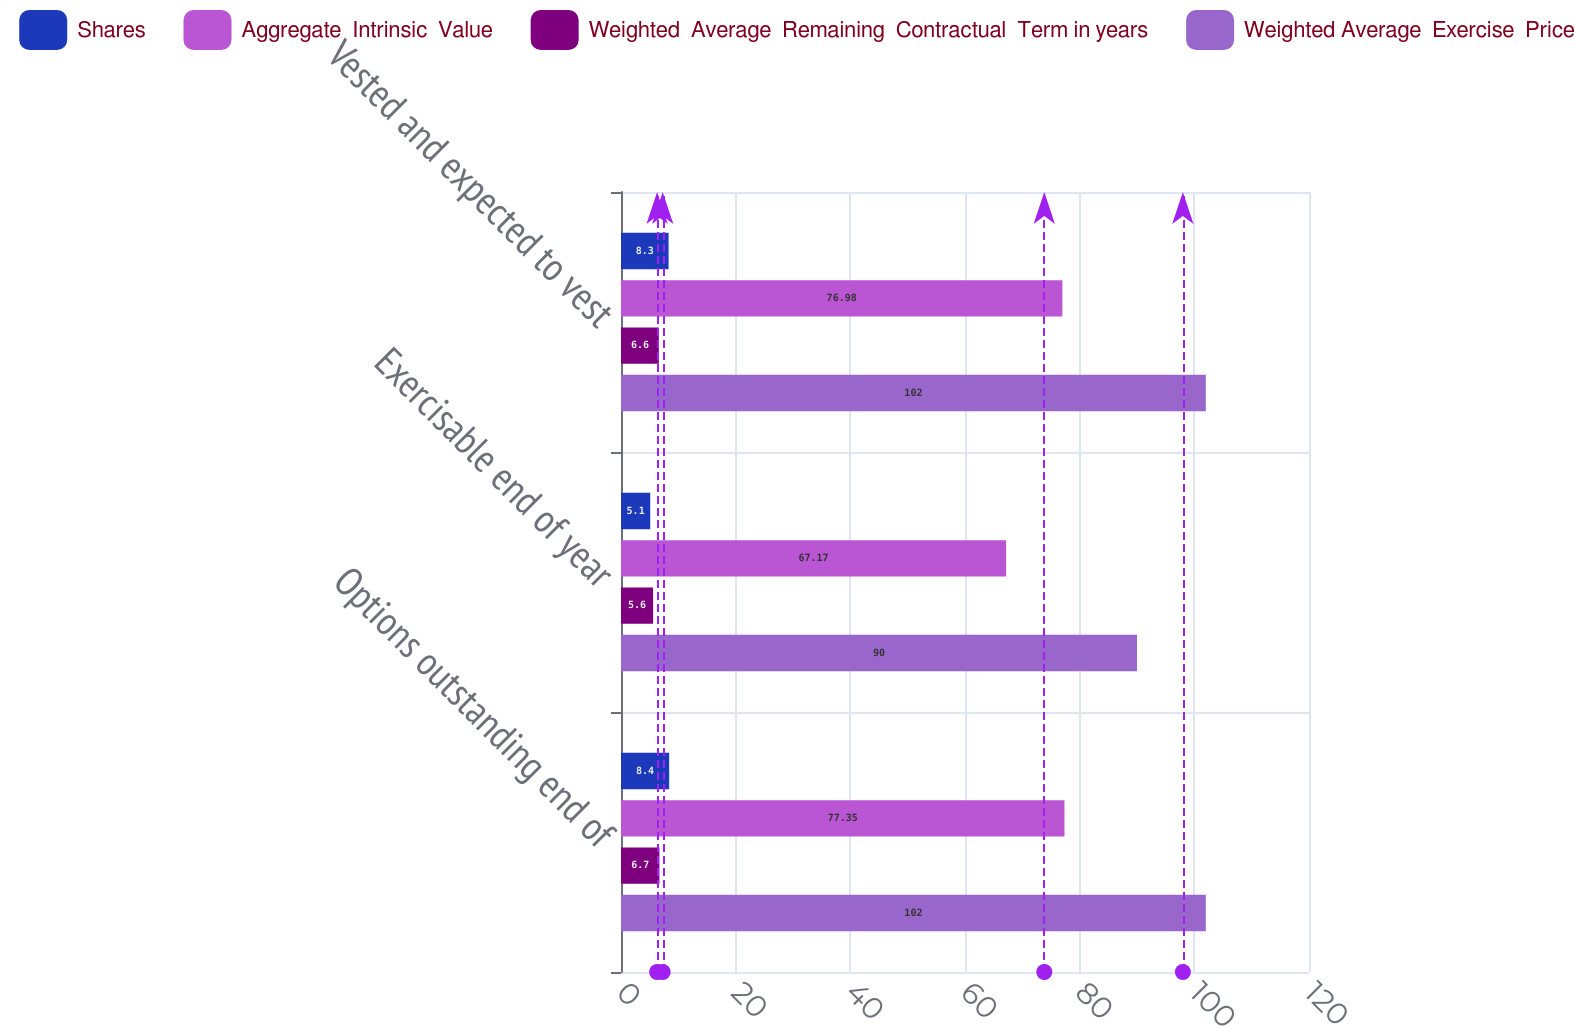Convert chart. <chart><loc_0><loc_0><loc_500><loc_500><stacked_bar_chart><ecel><fcel>Options outstanding end of<fcel>Exercisable end of year<fcel>Vested and expected to vest<nl><fcel>Shares<fcel>8.4<fcel>5.1<fcel>8.3<nl><fcel>Aggregate  Intrinsic  Value<fcel>77.35<fcel>67.17<fcel>76.98<nl><fcel>Weighted  Average  Remaining  Contractual  Term in years<fcel>6.7<fcel>5.6<fcel>6.6<nl><fcel>Weighted Average  Exercise  Price<fcel>102<fcel>90<fcel>102<nl></chart> 